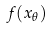Convert formula to latex. <formula><loc_0><loc_0><loc_500><loc_500>f ( x _ { \theta } )</formula> 